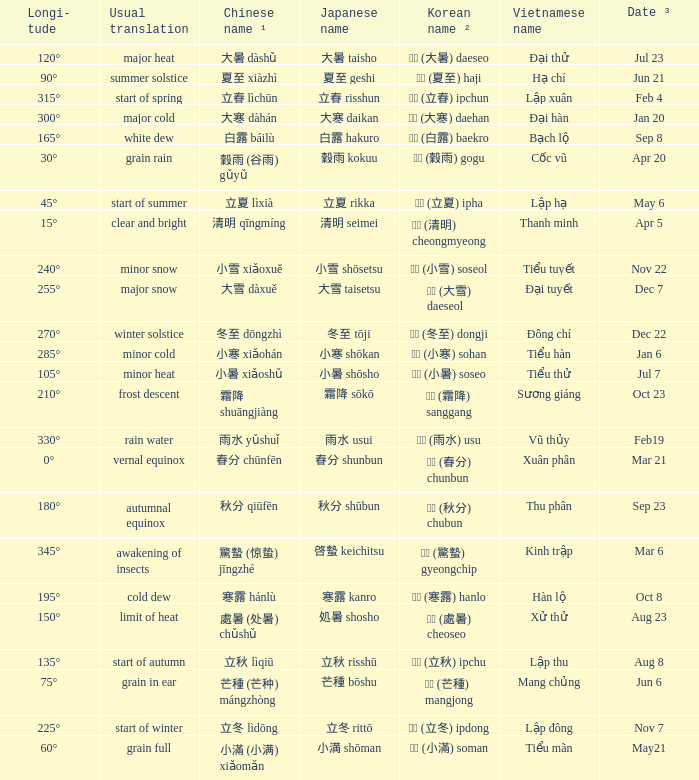WHICH Vietnamese name has a Chinese name ¹ of 芒種 (芒种) mángzhòng? Mang chủng. 